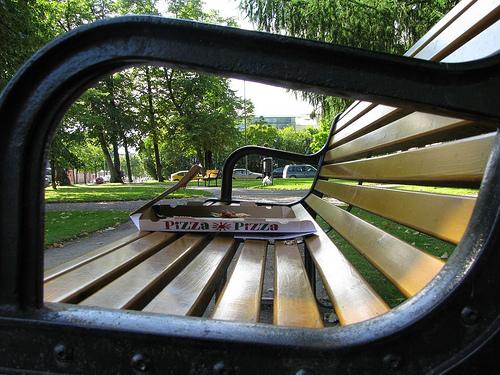Where is the pizza located?
Short answer required. On bench. Is the bench rusted?
Write a very short answer. No. How many cars are in the picture?
Short answer required. 3. 